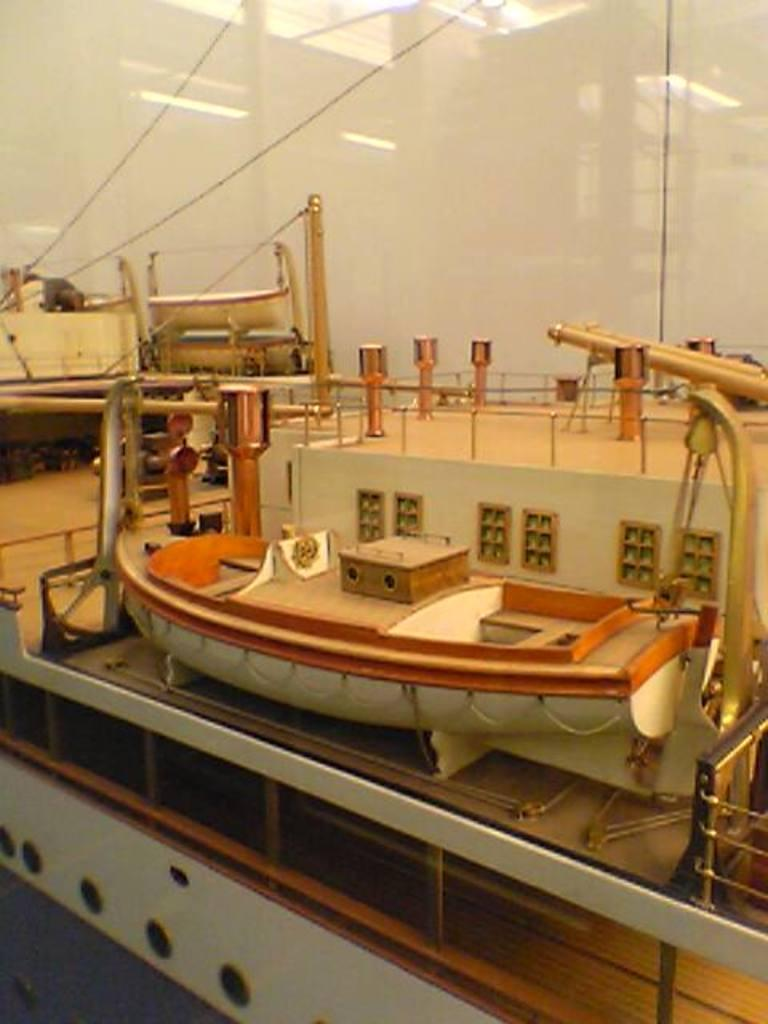What type of boat is in the image? There is an e-boat in the image. Where is the e-boat located in the image? The e-boat is in the center of the image. How is the e-boat displayed in the image? The e-boat is placed inside a glass. What advice does the kitten give about the e-boat in the boat in the image? There is no kitten present in the image, so it cannot provide any advice about the e-boat. 